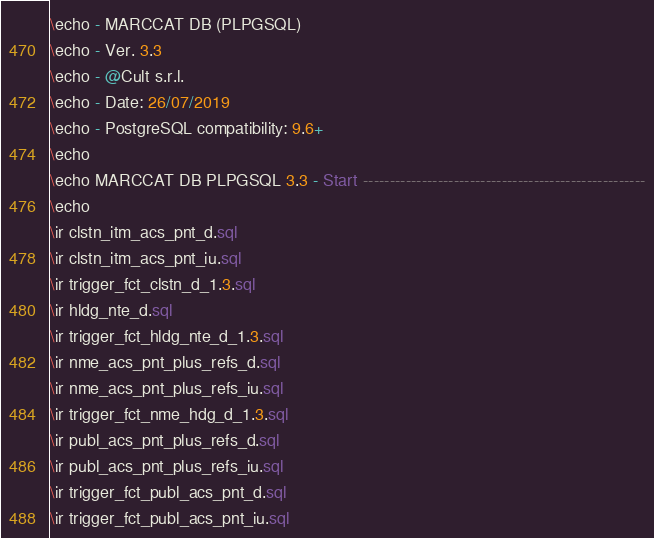<code> <loc_0><loc_0><loc_500><loc_500><_SQL_>\echo - MARCCAT DB (PLPGSQL)
\echo - Ver. 3.3
\echo - @Cult s.r.l.
\echo - Date: 26/07/2019
\echo - PostgreSQL compatibility: 9.6+
\echo
\echo MARCCAT DB PLPGSQL 3.3 - Start -----------------------------------------------------
\echo
\ir clstn_itm_acs_pnt_d.sql
\ir clstn_itm_acs_pnt_iu.sql
\ir trigger_fct_clstn_d_1.3.sql
\ir hldg_nte_d.sql
\ir trigger_fct_hldg_nte_d_1.3.sql
\ir nme_acs_pnt_plus_refs_d.sql
\ir nme_acs_pnt_plus_refs_iu.sql
\ir trigger_fct_nme_hdg_d_1.3.sql
\ir publ_acs_pnt_plus_refs_d.sql
\ir publ_acs_pnt_plus_refs_iu.sql
\ir trigger_fct_publ_acs_pnt_d.sql
\ir trigger_fct_publ_acs_pnt_iu.sql</code> 